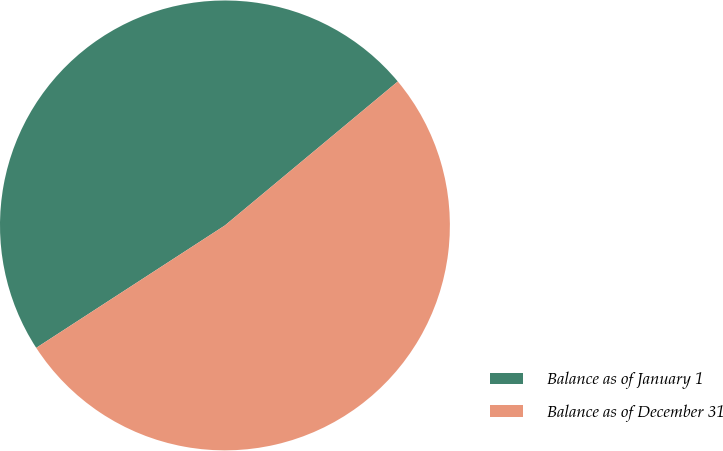Convert chart. <chart><loc_0><loc_0><loc_500><loc_500><pie_chart><fcel>Balance as of January 1<fcel>Balance as of December 31<nl><fcel>48.11%<fcel>51.89%<nl></chart> 